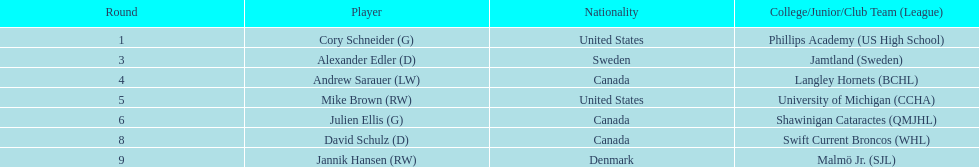Which player has canadian nationality and attended langley hornets? Andrew Sarauer (LW). 